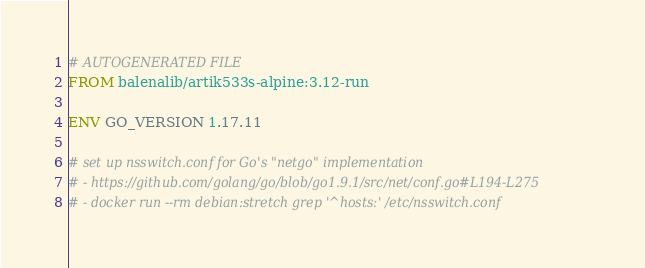Convert code to text. <code><loc_0><loc_0><loc_500><loc_500><_Dockerfile_># AUTOGENERATED FILE
FROM balenalib/artik533s-alpine:3.12-run

ENV GO_VERSION 1.17.11

# set up nsswitch.conf for Go's "netgo" implementation
# - https://github.com/golang/go/blob/go1.9.1/src/net/conf.go#L194-L275
# - docker run --rm debian:stretch grep '^hosts:' /etc/nsswitch.conf</code> 